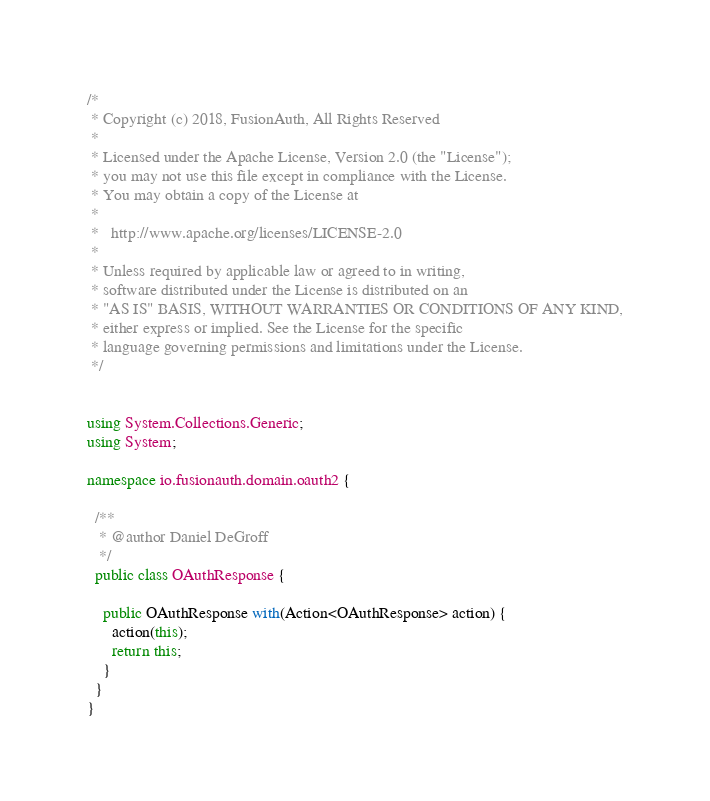Convert code to text. <code><loc_0><loc_0><loc_500><loc_500><_C#_>/*
 * Copyright (c) 2018, FusionAuth, All Rights Reserved
 *
 * Licensed under the Apache License, Version 2.0 (the "License");
 * you may not use this file except in compliance with the License.
 * You may obtain a copy of the License at
 *
 *   http://www.apache.org/licenses/LICENSE-2.0
 *
 * Unless required by applicable law or agreed to in writing,
 * software distributed under the License is distributed on an
 * "AS IS" BASIS, WITHOUT WARRANTIES OR CONDITIONS OF ANY KIND,
 * either express or implied. See the License for the specific
 * language governing permissions and limitations under the License.
 */


using System.Collections.Generic;
using System;

namespace io.fusionauth.domain.oauth2 {

  /**
   * @author Daniel DeGroff
   */
  public class OAuthResponse {

    public OAuthResponse with(Action<OAuthResponse> action) {
      action(this);
      return this;
    }
  }
}
</code> 